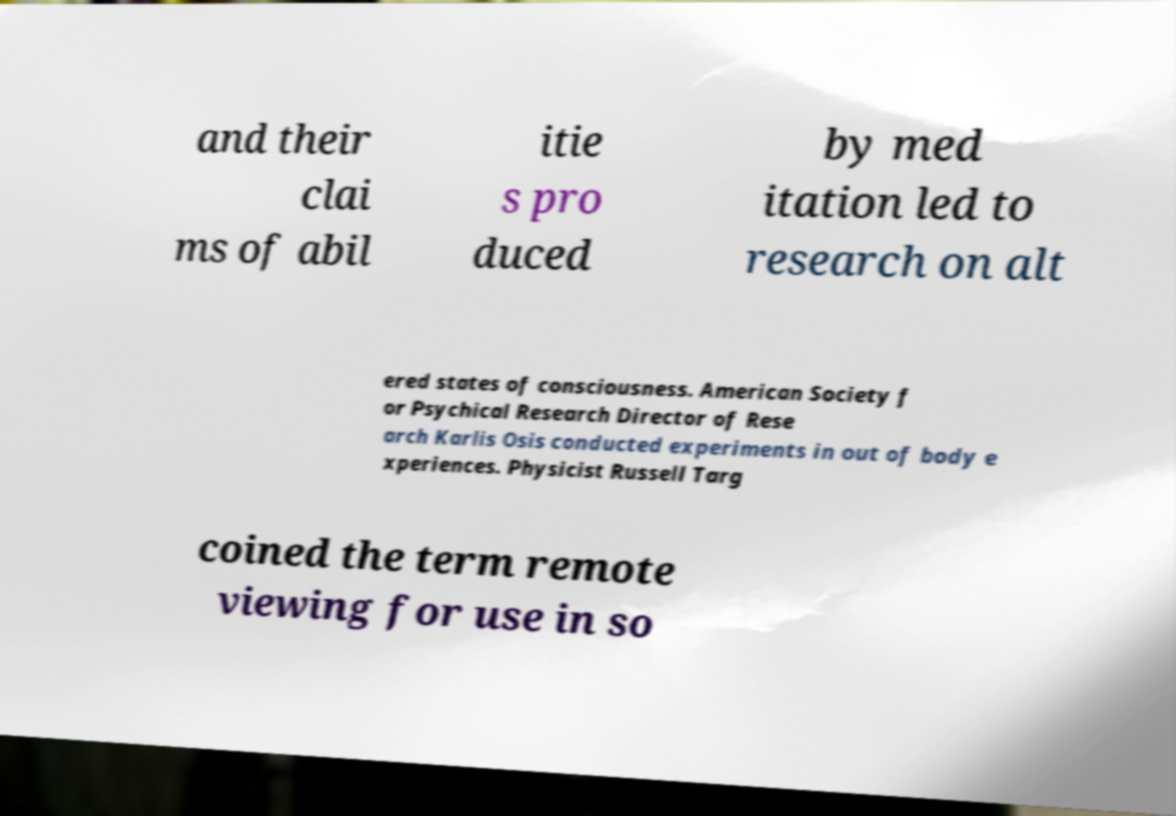Could you extract and type out the text from this image? and their clai ms of abil itie s pro duced by med itation led to research on alt ered states of consciousness. American Society f or Psychical Research Director of Rese arch Karlis Osis conducted experiments in out of body e xperiences. Physicist Russell Targ coined the term remote viewing for use in so 